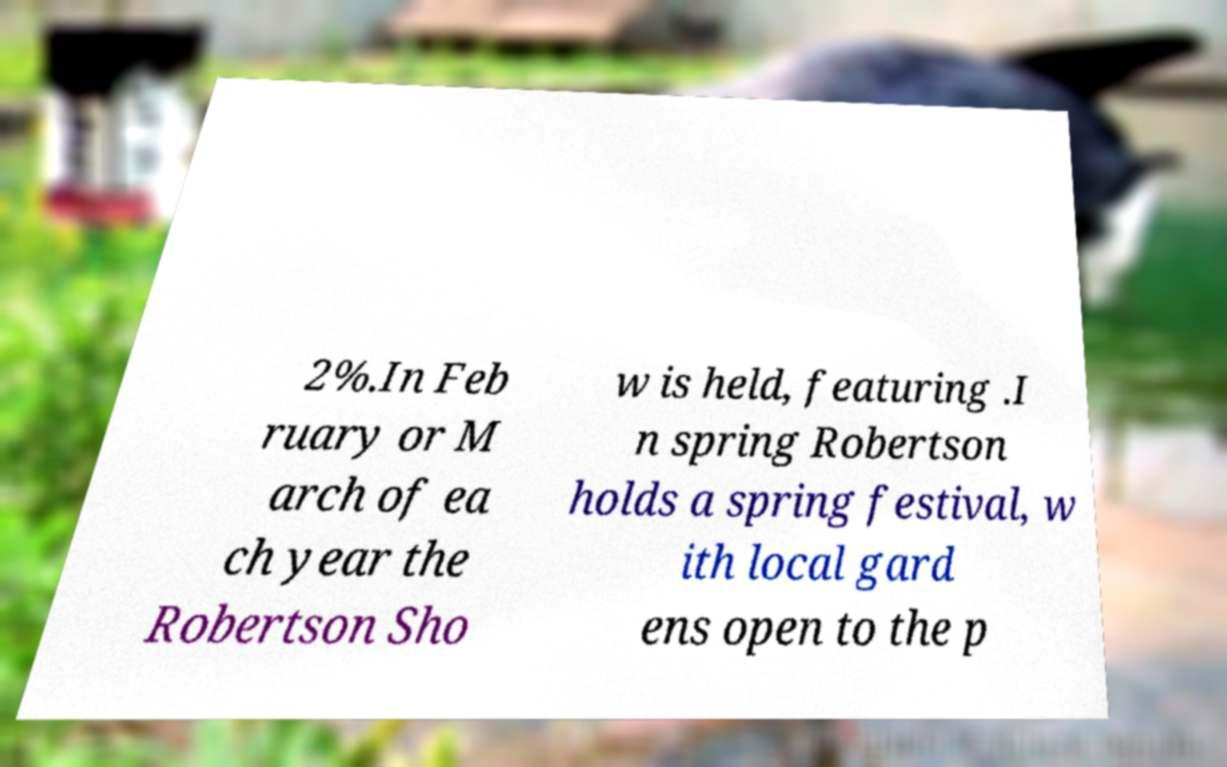What messages or text are displayed in this image? I need them in a readable, typed format. 2%.In Feb ruary or M arch of ea ch year the Robertson Sho w is held, featuring .I n spring Robertson holds a spring festival, w ith local gard ens open to the p 